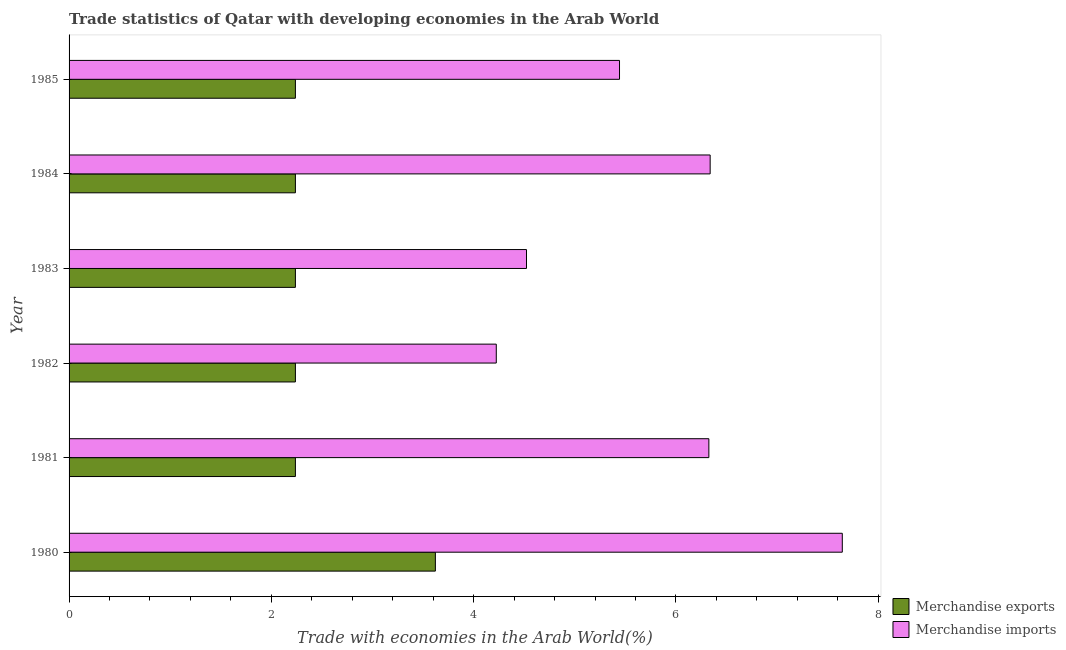How many bars are there on the 3rd tick from the bottom?
Your answer should be very brief. 2. In how many cases, is the number of bars for a given year not equal to the number of legend labels?
Make the answer very short. 0. What is the merchandise imports in 1982?
Provide a succinct answer. 4.22. Across all years, what is the maximum merchandise imports?
Your answer should be very brief. 7.64. Across all years, what is the minimum merchandise imports?
Offer a terse response. 4.22. In which year was the merchandise imports maximum?
Keep it short and to the point. 1980. What is the total merchandise imports in the graph?
Offer a terse response. 34.49. What is the difference between the merchandise imports in 1982 and that in 1983?
Your answer should be compact. -0.3. What is the difference between the merchandise exports in 1981 and the merchandise imports in 1980?
Provide a short and direct response. -5.41. What is the average merchandise imports per year?
Ensure brevity in your answer.  5.75. What is the ratio of the merchandise imports in 1981 to that in 1984?
Your response must be concise. 1. Is the difference between the merchandise imports in 1980 and 1985 greater than the difference between the merchandise exports in 1980 and 1985?
Ensure brevity in your answer.  Yes. What is the difference between the highest and the second highest merchandise exports?
Your answer should be very brief. 1.38. What is the difference between the highest and the lowest merchandise exports?
Make the answer very short. 1.38. What does the 1st bar from the top in 1983 represents?
Provide a succinct answer. Merchandise imports. What does the 1st bar from the bottom in 1980 represents?
Offer a very short reply. Merchandise exports. How many years are there in the graph?
Your response must be concise. 6. Are the values on the major ticks of X-axis written in scientific E-notation?
Your response must be concise. No. Does the graph contain any zero values?
Keep it short and to the point. No. Does the graph contain grids?
Give a very brief answer. No. How many legend labels are there?
Provide a short and direct response. 2. What is the title of the graph?
Provide a short and direct response. Trade statistics of Qatar with developing economies in the Arab World. Does "Highest 10% of population" appear as one of the legend labels in the graph?
Your answer should be very brief. No. What is the label or title of the X-axis?
Make the answer very short. Trade with economies in the Arab World(%). What is the Trade with economies in the Arab World(%) of Merchandise exports in 1980?
Your response must be concise. 3.62. What is the Trade with economies in the Arab World(%) in Merchandise imports in 1980?
Your answer should be compact. 7.64. What is the Trade with economies in the Arab World(%) of Merchandise exports in 1981?
Your response must be concise. 2.24. What is the Trade with economies in the Arab World(%) in Merchandise imports in 1981?
Give a very brief answer. 6.33. What is the Trade with economies in the Arab World(%) in Merchandise exports in 1982?
Your answer should be compact. 2.24. What is the Trade with economies in the Arab World(%) of Merchandise imports in 1982?
Provide a short and direct response. 4.22. What is the Trade with economies in the Arab World(%) of Merchandise exports in 1983?
Ensure brevity in your answer.  2.24. What is the Trade with economies in the Arab World(%) in Merchandise imports in 1983?
Provide a succinct answer. 4.52. What is the Trade with economies in the Arab World(%) of Merchandise exports in 1984?
Give a very brief answer. 2.24. What is the Trade with economies in the Arab World(%) of Merchandise imports in 1984?
Make the answer very short. 6.34. What is the Trade with economies in the Arab World(%) in Merchandise exports in 1985?
Offer a terse response. 2.24. What is the Trade with economies in the Arab World(%) of Merchandise imports in 1985?
Provide a short and direct response. 5.44. Across all years, what is the maximum Trade with economies in the Arab World(%) in Merchandise exports?
Ensure brevity in your answer.  3.62. Across all years, what is the maximum Trade with economies in the Arab World(%) of Merchandise imports?
Your answer should be very brief. 7.64. Across all years, what is the minimum Trade with economies in the Arab World(%) of Merchandise exports?
Give a very brief answer. 2.24. Across all years, what is the minimum Trade with economies in the Arab World(%) in Merchandise imports?
Make the answer very short. 4.22. What is the total Trade with economies in the Arab World(%) of Merchandise exports in the graph?
Offer a terse response. 14.81. What is the total Trade with economies in the Arab World(%) of Merchandise imports in the graph?
Provide a succinct answer. 34.49. What is the difference between the Trade with economies in the Arab World(%) of Merchandise exports in 1980 and that in 1981?
Offer a very short reply. 1.38. What is the difference between the Trade with economies in the Arab World(%) in Merchandise imports in 1980 and that in 1981?
Offer a very short reply. 1.32. What is the difference between the Trade with economies in the Arab World(%) in Merchandise exports in 1980 and that in 1982?
Your answer should be compact. 1.38. What is the difference between the Trade with economies in the Arab World(%) in Merchandise imports in 1980 and that in 1982?
Ensure brevity in your answer.  3.42. What is the difference between the Trade with economies in the Arab World(%) in Merchandise exports in 1980 and that in 1983?
Give a very brief answer. 1.38. What is the difference between the Trade with economies in the Arab World(%) of Merchandise imports in 1980 and that in 1983?
Make the answer very short. 3.12. What is the difference between the Trade with economies in the Arab World(%) of Merchandise exports in 1980 and that in 1984?
Ensure brevity in your answer.  1.38. What is the difference between the Trade with economies in the Arab World(%) of Merchandise imports in 1980 and that in 1984?
Make the answer very short. 1.31. What is the difference between the Trade with economies in the Arab World(%) of Merchandise exports in 1980 and that in 1985?
Make the answer very short. 1.38. What is the difference between the Trade with economies in the Arab World(%) of Merchandise imports in 1980 and that in 1985?
Give a very brief answer. 2.2. What is the difference between the Trade with economies in the Arab World(%) in Merchandise imports in 1981 and that in 1982?
Keep it short and to the point. 2.1. What is the difference between the Trade with economies in the Arab World(%) in Merchandise exports in 1981 and that in 1983?
Provide a succinct answer. 0. What is the difference between the Trade with economies in the Arab World(%) in Merchandise imports in 1981 and that in 1983?
Your answer should be compact. 1.8. What is the difference between the Trade with economies in the Arab World(%) in Merchandise exports in 1981 and that in 1984?
Offer a terse response. -0. What is the difference between the Trade with economies in the Arab World(%) of Merchandise imports in 1981 and that in 1984?
Make the answer very short. -0.01. What is the difference between the Trade with economies in the Arab World(%) of Merchandise exports in 1981 and that in 1985?
Give a very brief answer. 0. What is the difference between the Trade with economies in the Arab World(%) of Merchandise imports in 1981 and that in 1985?
Offer a terse response. 0.88. What is the difference between the Trade with economies in the Arab World(%) of Merchandise exports in 1982 and that in 1983?
Your answer should be compact. -0. What is the difference between the Trade with economies in the Arab World(%) of Merchandise imports in 1982 and that in 1983?
Ensure brevity in your answer.  -0.3. What is the difference between the Trade with economies in the Arab World(%) in Merchandise imports in 1982 and that in 1984?
Your response must be concise. -2.11. What is the difference between the Trade with economies in the Arab World(%) in Merchandise exports in 1982 and that in 1985?
Offer a terse response. -0. What is the difference between the Trade with economies in the Arab World(%) of Merchandise imports in 1982 and that in 1985?
Provide a short and direct response. -1.22. What is the difference between the Trade with economies in the Arab World(%) of Merchandise imports in 1983 and that in 1984?
Ensure brevity in your answer.  -1.82. What is the difference between the Trade with economies in the Arab World(%) of Merchandise exports in 1983 and that in 1985?
Your answer should be very brief. 0. What is the difference between the Trade with economies in the Arab World(%) of Merchandise imports in 1983 and that in 1985?
Provide a short and direct response. -0.92. What is the difference between the Trade with economies in the Arab World(%) of Merchandise imports in 1984 and that in 1985?
Keep it short and to the point. 0.9. What is the difference between the Trade with economies in the Arab World(%) in Merchandise exports in 1980 and the Trade with economies in the Arab World(%) in Merchandise imports in 1981?
Offer a very short reply. -2.7. What is the difference between the Trade with economies in the Arab World(%) of Merchandise exports in 1980 and the Trade with economies in the Arab World(%) of Merchandise imports in 1982?
Ensure brevity in your answer.  -0.6. What is the difference between the Trade with economies in the Arab World(%) in Merchandise exports in 1980 and the Trade with economies in the Arab World(%) in Merchandise imports in 1983?
Offer a very short reply. -0.9. What is the difference between the Trade with economies in the Arab World(%) in Merchandise exports in 1980 and the Trade with economies in the Arab World(%) in Merchandise imports in 1984?
Your response must be concise. -2.72. What is the difference between the Trade with economies in the Arab World(%) of Merchandise exports in 1980 and the Trade with economies in the Arab World(%) of Merchandise imports in 1985?
Offer a very short reply. -1.82. What is the difference between the Trade with economies in the Arab World(%) of Merchandise exports in 1981 and the Trade with economies in the Arab World(%) of Merchandise imports in 1982?
Provide a short and direct response. -1.99. What is the difference between the Trade with economies in the Arab World(%) in Merchandise exports in 1981 and the Trade with economies in the Arab World(%) in Merchandise imports in 1983?
Give a very brief answer. -2.28. What is the difference between the Trade with economies in the Arab World(%) of Merchandise exports in 1981 and the Trade with economies in the Arab World(%) of Merchandise imports in 1984?
Your answer should be very brief. -4.1. What is the difference between the Trade with economies in the Arab World(%) in Merchandise exports in 1981 and the Trade with economies in the Arab World(%) in Merchandise imports in 1985?
Keep it short and to the point. -3.2. What is the difference between the Trade with economies in the Arab World(%) of Merchandise exports in 1982 and the Trade with economies in the Arab World(%) of Merchandise imports in 1983?
Your response must be concise. -2.28. What is the difference between the Trade with economies in the Arab World(%) in Merchandise exports in 1982 and the Trade with economies in the Arab World(%) in Merchandise imports in 1984?
Offer a terse response. -4.1. What is the difference between the Trade with economies in the Arab World(%) of Merchandise exports in 1982 and the Trade with economies in the Arab World(%) of Merchandise imports in 1985?
Your answer should be very brief. -3.2. What is the difference between the Trade with economies in the Arab World(%) of Merchandise exports in 1983 and the Trade with economies in the Arab World(%) of Merchandise imports in 1984?
Provide a short and direct response. -4.1. What is the difference between the Trade with economies in the Arab World(%) of Merchandise exports in 1983 and the Trade with economies in the Arab World(%) of Merchandise imports in 1985?
Your answer should be compact. -3.2. What is the difference between the Trade with economies in the Arab World(%) of Merchandise exports in 1984 and the Trade with economies in the Arab World(%) of Merchandise imports in 1985?
Provide a succinct answer. -3.2. What is the average Trade with economies in the Arab World(%) of Merchandise exports per year?
Make the answer very short. 2.47. What is the average Trade with economies in the Arab World(%) in Merchandise imports per year?
Ensure brevity in your answer.  5.75. In the year 1980, what is the difference between the Trade with economies in the Arab World(%) of Merchandise exports and Trade with economies in the Arab World(%) of Merchandise imports?
Your answer should be very brief. -4.02. In the year 1981, what is the difference between the Trade with economies in the Arab World(%) of Merchandise exports and Trade with economies in the Arab World(%) of Merchandise imports?
Make the answer very short. -4.09. In the year 1982, what is the difference between the Trade with economies in the Arab World(%) of Merchandise exports and Trade with economies in the Arab World(%) of Merchandise imports?
Provide a succinct answer. -1.99. In the year 1983, what is the difference between the Trade with economies in the Arab World(%) in Merchandise exports and Trade with economies in the Arab World(%) in Merchandise imports?
Offer a terse response. -2.28. In the year 1984, what is the difference between the Trade with economies in the Arab World(%) in Merchandise exports and Trade with economies in the Arab World(%) in Merchandise imports?
Offer a terse response. -4.1. In the year 1985, what is the difference between the Trade with economies in the Arab World(%) in Merchandise exports and Trade with economies in the Arab World(%) in Merchandise imports?
Ensure brevity in your answer.  -3.2. What is the ratio of the Trade with economies in the Arab World(%) of Merchandise exports in 1980 to that in 1981?
Make the answer very short. 1.62. What is the ratio of the Trade with economies in the Arab World(%) of Merchandise imports in 1980 to that in 1981?
Make the answer very short. 1.21. What is the ratio of the Trade with economies in the Arab World(%) of Merchandise exports in 1980 to that in 1982?
Offer a very short reply. 1.62. What is the ratio of the Trade with economies in the Arab World(%) of Merchandise imports in 1980 to that in 1982?
Your answer should be compact. 1.81. What is the ratio of the Trade with economies in the Arab World(%) of Merchandise exports in 1980 to that in 1983?
Offer a very short reply. 1.62. What is the ratio of the Trade with economies in the Arab World(%) in Merchandise imports in 1980 to that in 1983?
Make the answer very short. 1.69. What is the ratio of the Trade with economies in the Arab World(%) of Merchandise exports in 1980 to that in 1984?
Ensure brevity in your answer.  1.62. What is the ratio of the Trade with economies in the Arab World(%) in Merchandise imports in 1980 to that in 1984?
Keep it short and to the point. 1.21. What is the ratio of the Trade with economies in the Arab World(%) in Merchandise exports in 1980 to that in 1985?
Make the answer very short. 1.62. What is the ratio of the Trade with economies in the Arab World(%) in Merchandise imports in 1980 to that in 1985?
Keep it short and to the point. 1.4. What is the ratio of the Trade with economies in the Arab World(%) of Merchandise exports in 1981 to that in 1982?
Keep it short and to the point. 1. What is the ratio of the Trade with economies in the Arab World(%) of Merchandise imports in 1981 to that in 1982?
Give a very brief answer. 1.5. What is the ratio of the Trade with economies in the Arab World(%) of Merchandise exports in 1981 to that in 1983?
Keep it short and to the point. 1. What is the ratio of the Trade with economies in the Arab World(%) of Merchandise imports in 1981 to that in 1983?
Ensure brevity in your answer.  1.4. What is the ratio of the Trade with economies in the Arab World(%) of Merchandise imports in 1981 to that in 1984?
Keep it short and to the point. 1. What is the ratio of the Trade with economies in the Arab World(%) of Merchandise exports in 1981 to that in 1985?
Ensure brevity in your answer.  1. What is the ratio of the Trade with economies in the Arab World(%) in Merchandise imports in 1981 to that in 1985?
Offer a very short reply. 1.16. What is the ratio of the Trade with economies in the Arab World(%) in Merchandise exports in 1982 to that in 1983?
Give a very brief answer. 1. What is the ratio of the Trade with economies in the Arab World(%) of Merchandise imports in 1982 to that in 1983?
Give a very brief answer. 0.93. What is the ratio of the Trade with economies in the Arab World(%) of Merchandise exports in 1982 to that in 1984?
Provide a succinct answer. 1. What is the ratio of the Trade with economies in the Arab World(%) in Merchandise imports in 1982 to that in 1984?
Your response must be concise. 0.67. What is the ratio of the Trade with economies in the Arab World(%) in Merchandise exports in 1982 to that in 1985?
Provide a short and direct response. 1. What is the ratio of the Trade with economies in the Arab World(%) of Merchandise imports in 1982 to that in 1985?
Give a very brief answer. 0.78. What is the ratio of the Trade with economies in the Arab World(%) in Merchandise exports in 1983 to that in 1984?
Your response must be concise. 1. What is the ratio of the Trade with economies in the Arab World(%) of Merchandise imports in 1983 to that in 1984?
Ensure brevity in your answer.  0.71. What is the ratio of the Trade with economies in the Arab World(%) in Merchandise imports in 1983 to that in 1985?
Your answer should be compact. 0.83. What is the ratio of the Trade with economies in the Arab World(%) in Merchandise imports in 1984 to that in 1985?
Your response must be concise. 1.16. What is the difference between the highest and the second highest Trade with economies in the Arab World(%) of Merchandise exports?
Offer a very short reply. 1.38. What is the difference between the highest and the second highest Trade with economies in the Arab World(%) of Merchandise imports?
Offer a very short reply. 1.31. What is the difference between the highest and the lowest Trade with economies in the Arab World(%) in Merchandise exports?
Keep it short and to the point. 1.38. What is the difference between the highest and the lowest Trade with economies in the Arab World(%) in Merchandise imports?
Keep it short and to the point. 3.42. 